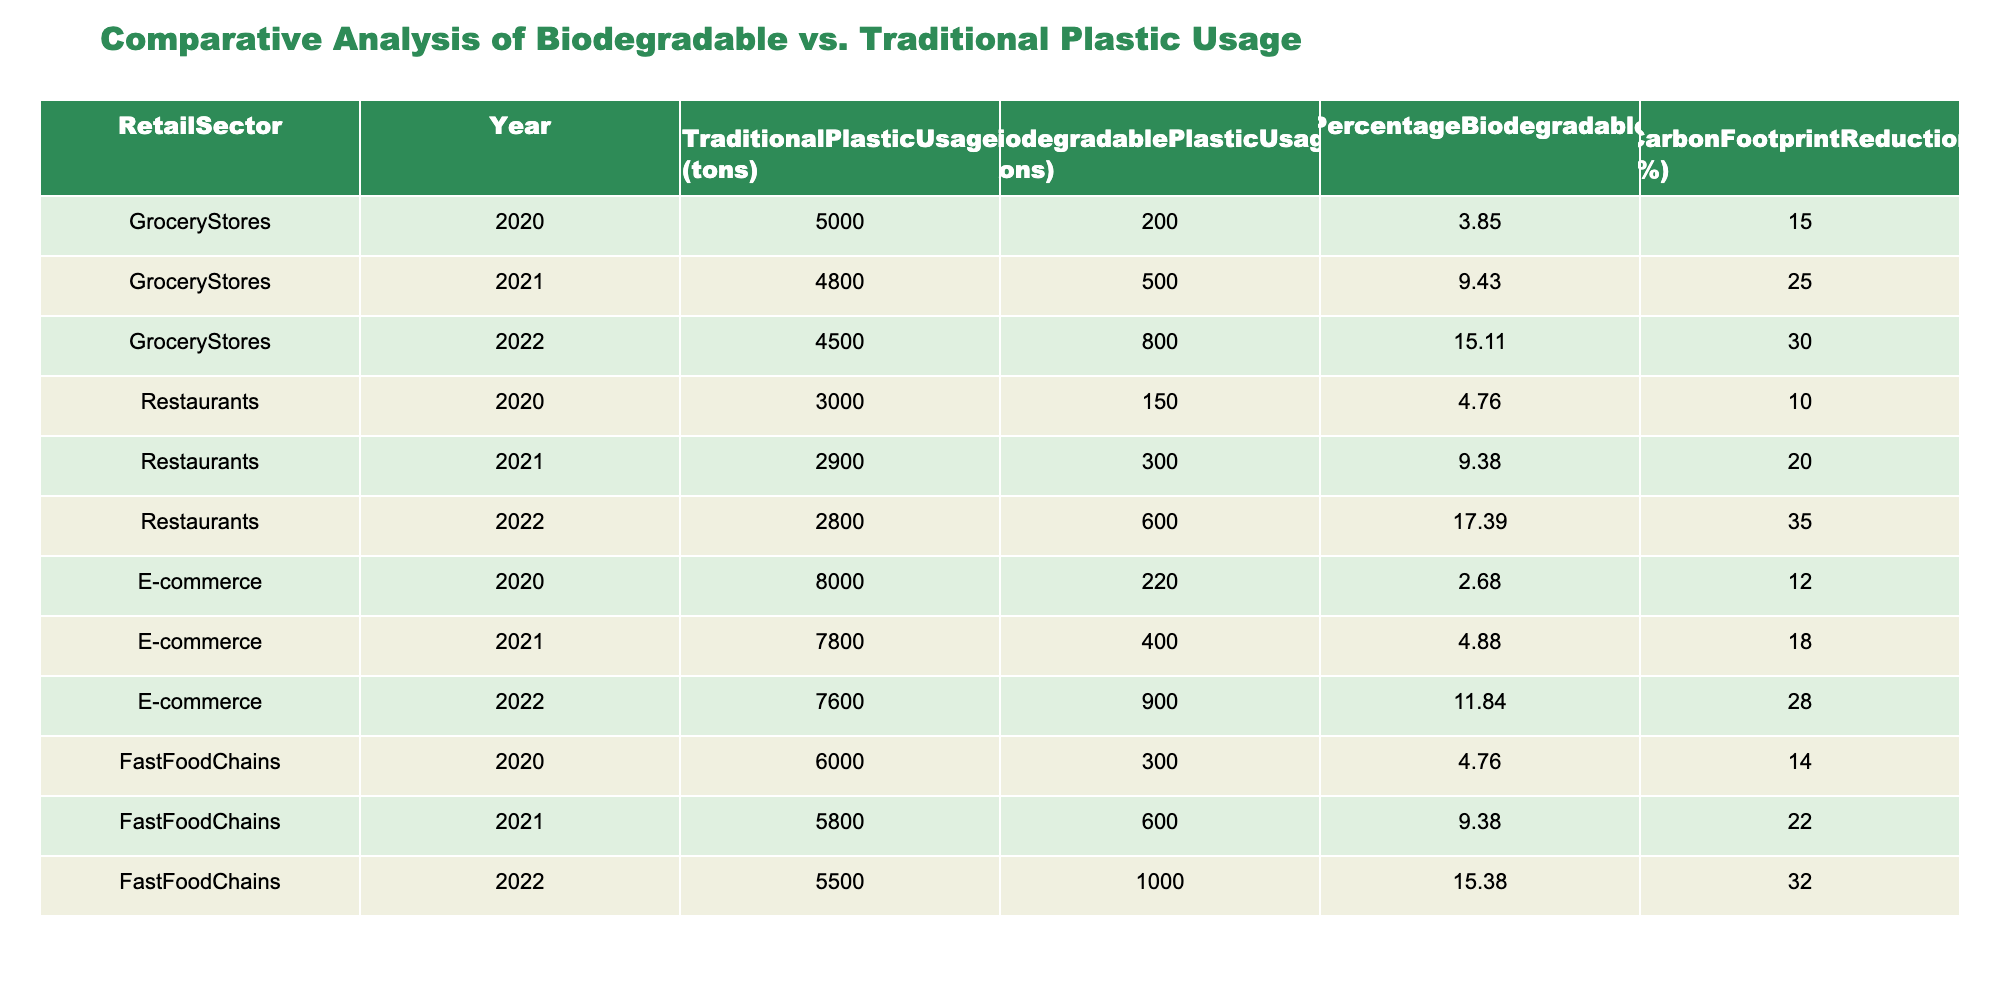What was the traditional plastic usage by Grocery Stores in 2021? The table shows that in 2021, Grocery Stores used 4800 tons of traditional plastic.
Answer: 4800 tons Which retail sector had the highest percentage of biodegradable plastic usage in 2022? In 2022, Fast Food Chains had 15.38% of their plastic usage as biodegradable, which is the highest percentage compared to the other sectors listed.
Answer: Fast Food Chains What is the total traditional plastic usage across all sectors in 2020? To find the total traditional plastic usage in 2020, we sum the usage from all sectors: 5000 (Grocery Stores) + 3000 (Restaurants) + 8000 (E-commerce) + 6000 (Fast Food Chains) = 22000 tons.
Answer: 22000 tons Did the usage of biodegradable plastics increase in the E-commerce sector from 2020 to 2022? Yes, it increased from 220 tons in 2020 to 900 tons in 2022, indicating a clear upward trend in biodegradable plastic usage.
Answer: Yes What was the average carbon footprint reduction percentage for Restaurants over the three years? The carbon footprint reduction percentages for Restaurants are 10%, 20%, and 35% for the years 2020, 2021, and 2022, respectively. To find the average, we sum them: 10 + 20 + 35 = 65, and divide by 3 (65/3 = 21.67).
Answer: 21.67% What was the percentage increase in biodegradable plastic usage for Grocery Stores from 2021 to 2022? In 2021, Grocery Stores used 500 tons of biodegradable plastic, and in 2022, they used 800 tons. The increase is 800 - 500 = 300 tons. To find the percentage increase, we divide the increase by the original amount: (300/500) * 100 = 60%.
Answer: 60% Which retail sector saw the lowest overall usage of biodegradable plastics in 2020? The table shows that E-commerce had the lowest usage of biodegradable plastics in 2020 with only 220 tons compared to other sectors.
Answer: E-commerce Was there a consistent year-over-year increase in the percentage of biodegradable plastic usage in the Fast Food Chains? Yes, the percentage increased from 4.76% in 2020 to 9.38% in 2021 and then to 15.38% in 2022, indicating a consistent upward trend.
Answer: Yes Calculate the total biodegradable plastic usage across all sectors in 2022. For 2022, the biodegradable plastic usage was 800 (Grocery Stores) + 600 (Restaurants) + 900 (E-commerce) + 1000 (Fast Food Chains) = 3300 tons total.
Answer: 3300 tons 